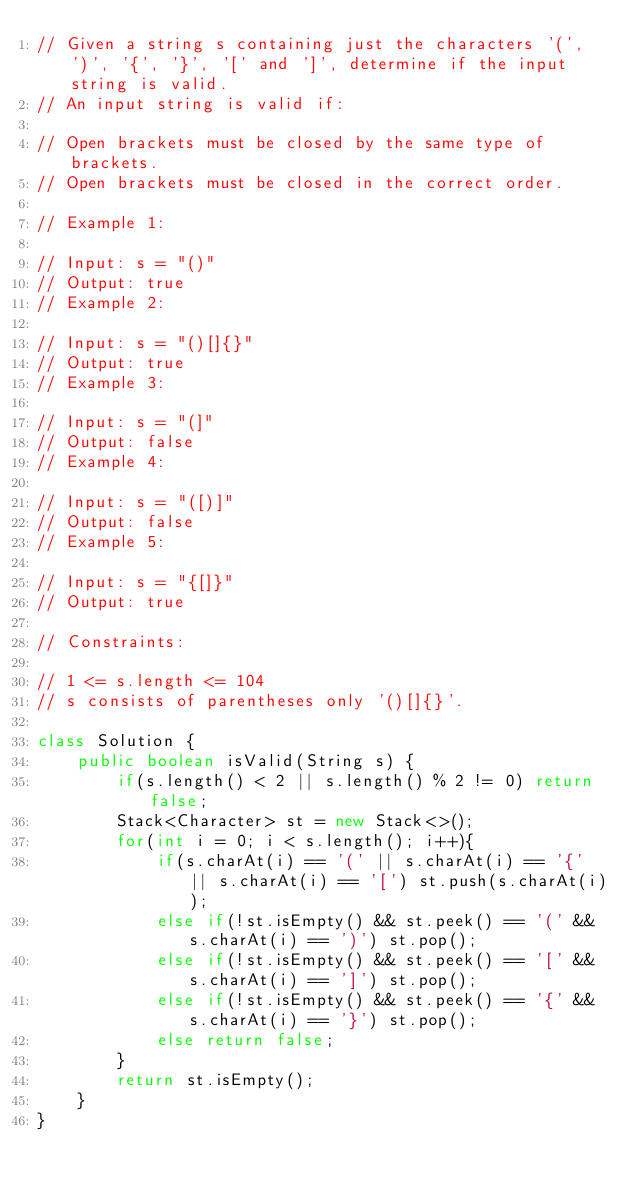<code> <loc_0><loc_0><loc_500><loc_500><_Java_>// Given a string s containing just the characters '(', ')', '{', '}', '[' and ']', determine if the input string is valid.
// An input string is valid if:

// Open brackets must be closed by the same type of brackets.
// Open brackets must be closed in the correct order.

// Example 1:

// Input: s = "()"
// Output: true
// Example 2:

// Input: s = "()[]{}"
// Output: true
// Example 3:

// Input: s = "(]"
// Output: false
// Example 4:

// Input: s = "([)]"
// Output: false
// Example 5:

// Input: s = "{[]}"
// Output: true 

// Constraints:

// 1 <= s.length <= 104
// s consists of parentheses only '()[]{}'.

class Solution {
    public boolean isValid(String s) {
        if(s.length() < 2 || s.length() % 2 != 0) return false;
        Stack<Character> st = new Stack<>();
        for(int i = 0; i < s.length(); i++){
            if(s.charAt(i) == '(' || s.charAt(i) == '{' || s.charAt(i) == '[') st.push(s.charAt(i));
            else if(!st.isEmpty() && st.peek() == '(' && s.charAt(i) == ')') st.pop();
            else if(!st.isEmpty() && st.peek() == '[' && s.charAt(i) == ']') st.pop();
            else if(!st.isEmpty() && st.peek() == '{' && s.charAt(i) == '}') st.pop();
            else return false;
        }
        return st.isEmpty();
    }
}</code> 